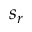Convert formula to latex. <formula><loc_0><loc_0><loc_500><loc_500>s _ { r }</formula> 